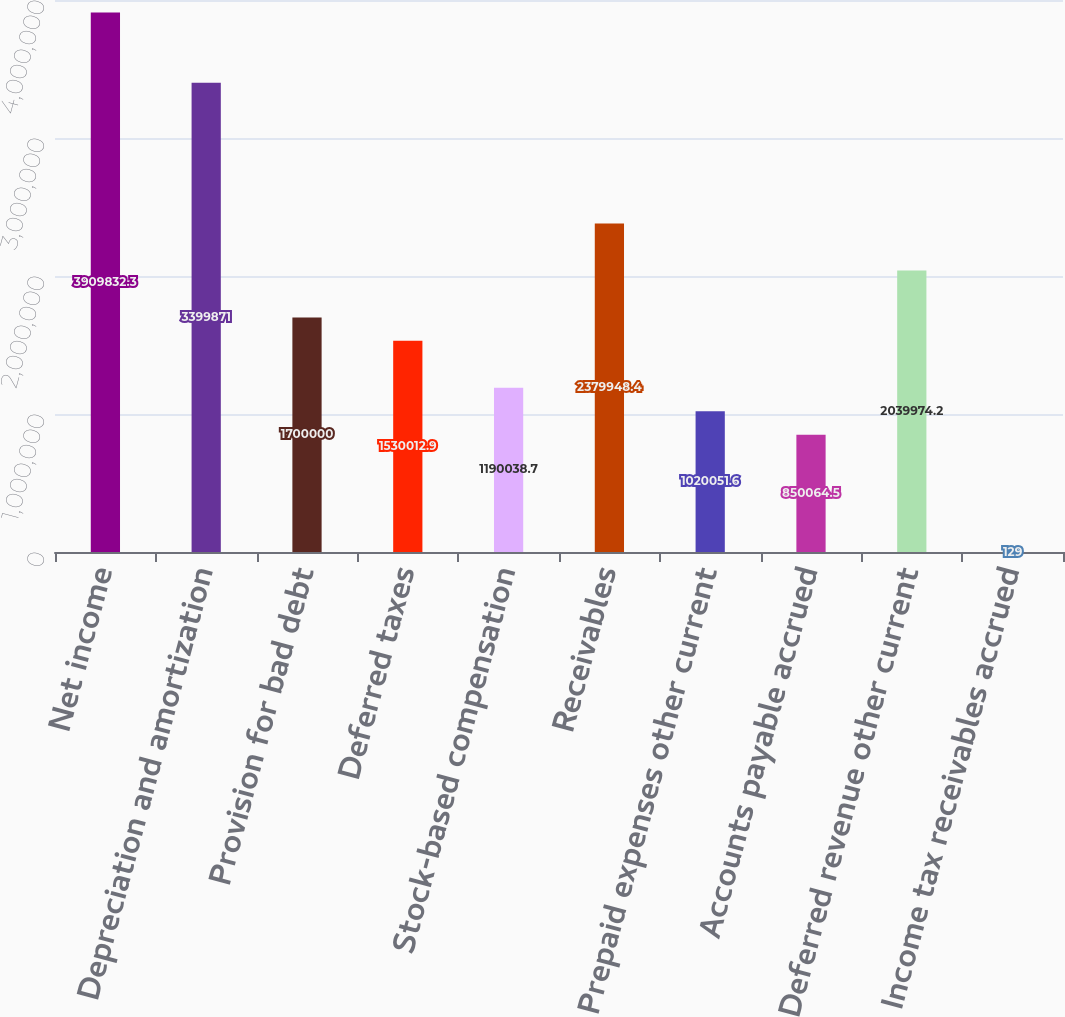Convert chart to OTSL. <chart><loc_0><loc_0><loc_500><loc_500><bar_chart><fcel>Net income<fcel>Depreciation and amortization<fcel>Provision for bad debt<fcel>Deferred taxes<fcel>Stock-based compensation<fcel>Receivables<fcel>Prepaid expenses other current<fcel>Accounts payable accrued<fcel>Deferred revenue other current<fcel>Income tax receivables accrued<nl><fcel>3.90983e+06<fcel>3.39987e+06<fcel>1.7e+06<fcel>1.53001e+06<fcel>1.19004e+06<fcel>2.37995e+06<fcel>1.02005e+06<fcel>850064<fcel>2.03997e+06<fcel>129<nl></chart> 